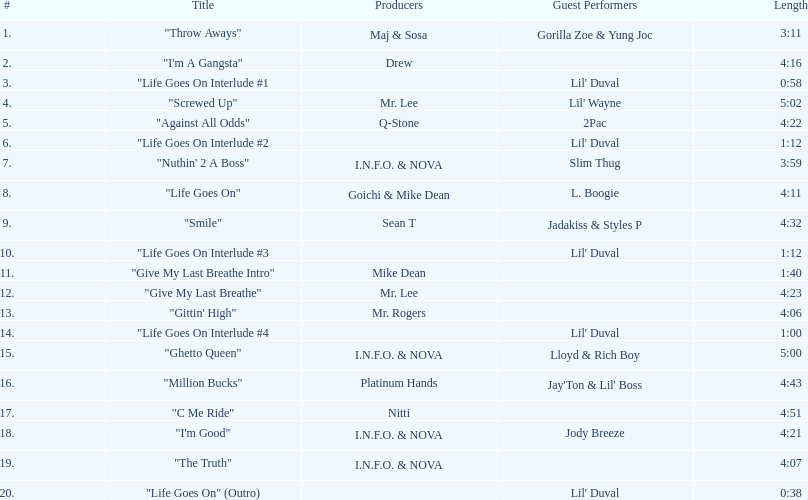How many tunes are there on trae's "life goes on" album? 20. Parse the full table. {'header': ['#', 'Title', 'Producers', 'Guest Performers', 'Length'], 'rows': [['1.', '"Throw Aways"', 'Maj & Sosa', 'Gorilla Zoe & Yung Joc', '3:11'], ['2.', '"I\'m A Gangsta"', 'Drew', '', '4:16'], ['3.', '"Life Goes On Interlude #1', '', "Lil' Duval", '0:58'], ['4.', '"Screwed Up"', 'Mr. Lee', "Lil' Wayne", '5:02'], ['5.', '"Against All Odds"', 'Q-Stone', '2Pac', '4:22'], ['6.', '"Life Goes On Interlude #2', '', "Lil' Duval", '1:12'], ['7.', '"Nuthin\' 2 A Boss"', 'I.N.F.O. & NOVA', 'Slim Thug', '3:59'], ['8.', '"Life Goes On"', 'Goichi & Mike Dean', 'L. Boogie', '4:11'], ['9.', '"Smile"', 'Sean T', 'Jadakiss & Styles P', '4:32'], ['10.', '"Life Goes On Interlude #3', '', "Lil' Duval", '1:12'], ['11.', '"Give My Last Breathe Intro"', 'Mike Dean', '', '1:40'], ['12.', '"Give My Last Breathe"', 'Mr. Lee', '', '4:23'], ['13.', '"Gittin\' High"', 'Mr. Rogers', '', '4:06'], ['14.', '"Life Goes On Interlude #4', '', "Lil' Duval", '1:00'], ['15.', '"Ghetto Queen"', 'I.N.F.O. & NOVA', 'Lloyd & Rich Boy', '5:00'], ['16.', '"Million Bucks"', 'Platinum Hands', "Jay'Ton & Lil' Boss", '4:43'], ['17.', '"C Me Ride"', 'Nitti', '', '4:51'], ['18.', '"I\'m Good"', 'I.N.F.O. & NOVA', 'Jody Breeze', '4:21'], ['19.', '"The Truth"', 'I.N.F.O. & NOVA', '', '4:07'], ['20.', '"Life Goes On" (Outro)', '', "Lil' Duval", '0:38']]} 